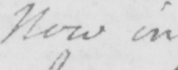What does this handwritten line say? Now in 